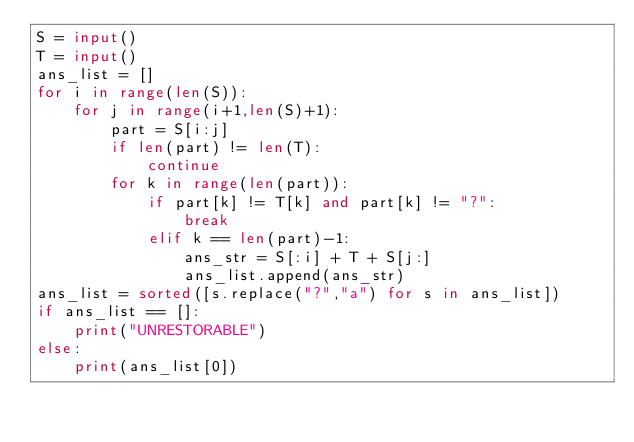<code> <loc_0><loc_0><loc_500><loc_500><_Python_>S = input()
T = input()
ans_list = []
for i in range(len(S)):
    for j in range(i+1,len(S)+1):
        part = S[i:j]
        if len(part) != len(T):
            continue
        for k in range(len(part)):
            if part[k] != T[k] and part[k] != "?":
                break
            elif k == len(part)-1:
                ans_str = S[:i] + T + S[j:]
                ans_list.append(ans_str)
ans_list = sorted([s.replace("?","a") for s in ans_list])
if ans_list == []:
    print("UNRESTORABLE")
else:
    print(ans_list[0])</code> 